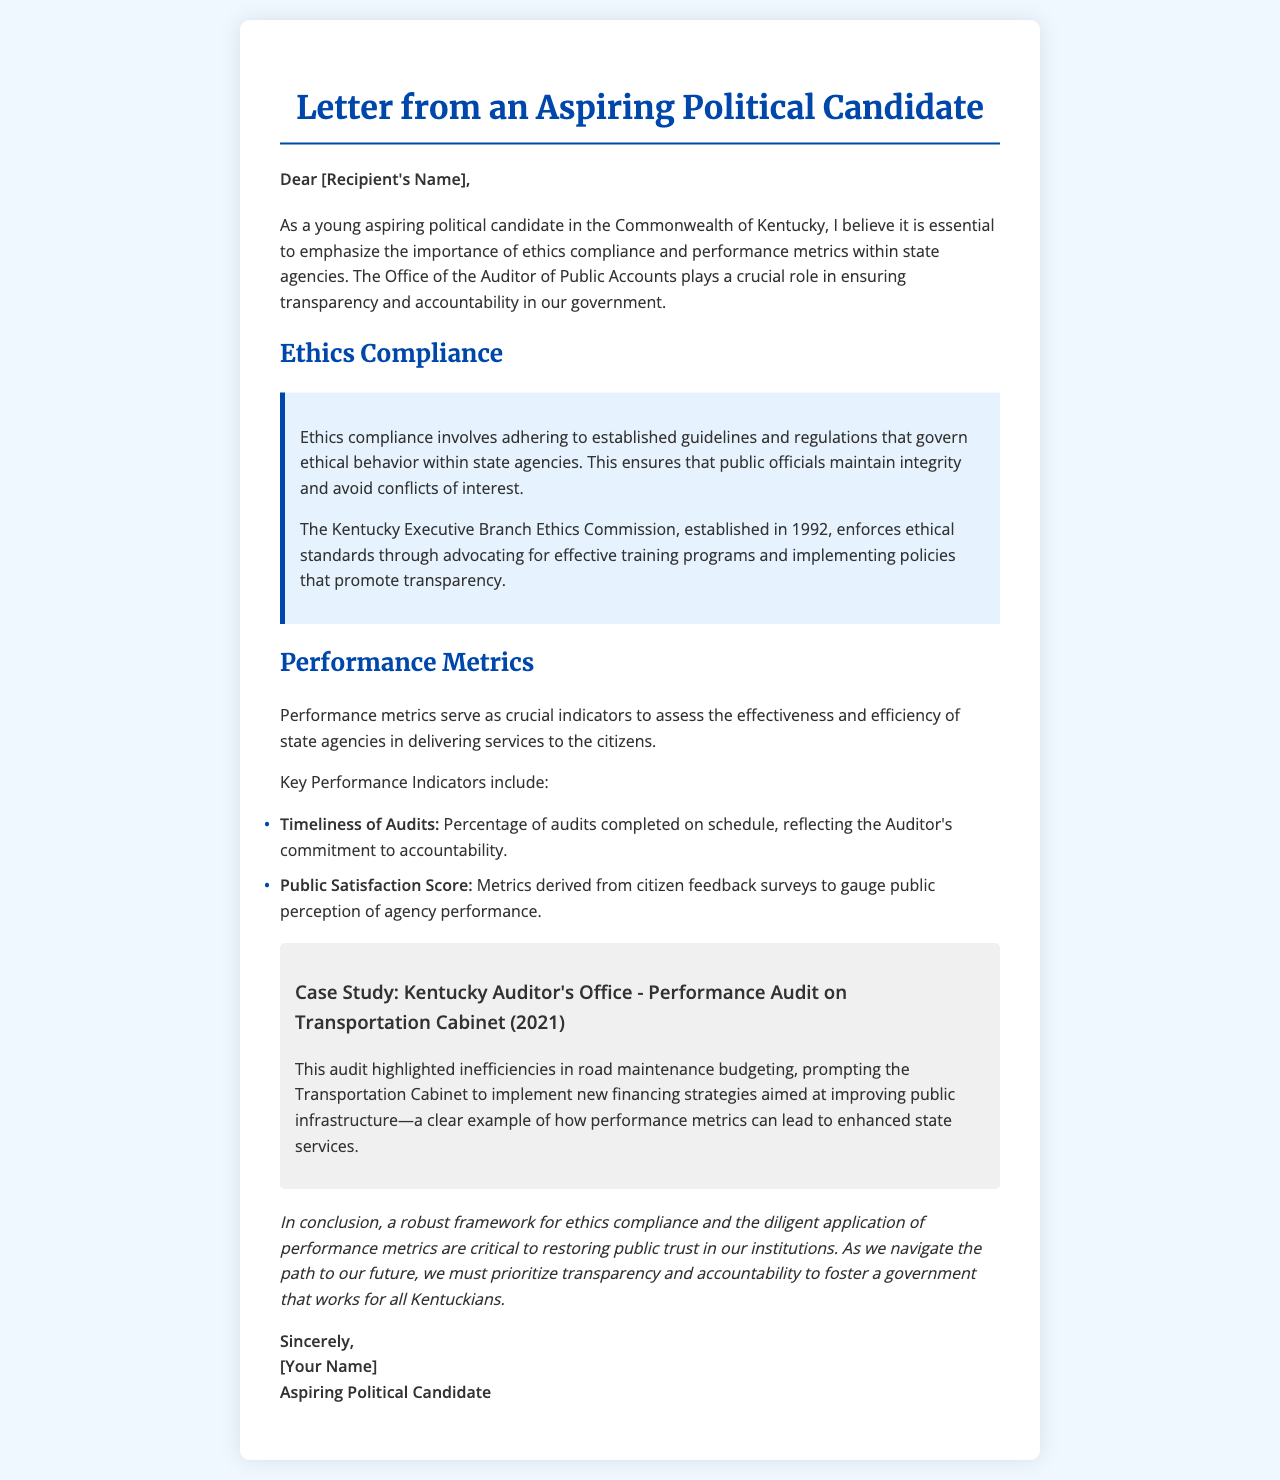What is the main focus of the letter? The main focus of the letter is on ethics compliance and performance metrics within state agencies in Kentucky.
Answer: ethics compliance and performance metrics Who established the Kentucky Executive Branch Ethics Commission? The letter mentions that the Kentucky Executive Branch Ethics Commission was established in 1992.
Answer: 1992 What is one of the Key Performance Indicators mentioned? The letter lists "Timeliness of Audits" as a Key Performance Indicator.
Answer: Timeliness of Audits What case study is referenced in the document? The document references a performance audit on the Transportation Cabinet conducted by the Kentucky Auditor's Office in 2021.
Answer: Transportation Cabinet (2021) What does the author emphasize is essential for restoring public trust? The author emphasizes the importance of a robust framework for ethics compliance and performance metrics to restore public trust.
Answer: a robust framework for ethics compliance and performance metrics What was highlighted in the case study about the Transportation Cabinet? The case study highlighted inefficiencies in road maintenance budgeting.
Answer: inefficiencies in road maintenance budgeting What does the conclusion call for? The conclusion calls for prioritizing transparency and accountability.
Answer: prioritizing transparency and accountability 